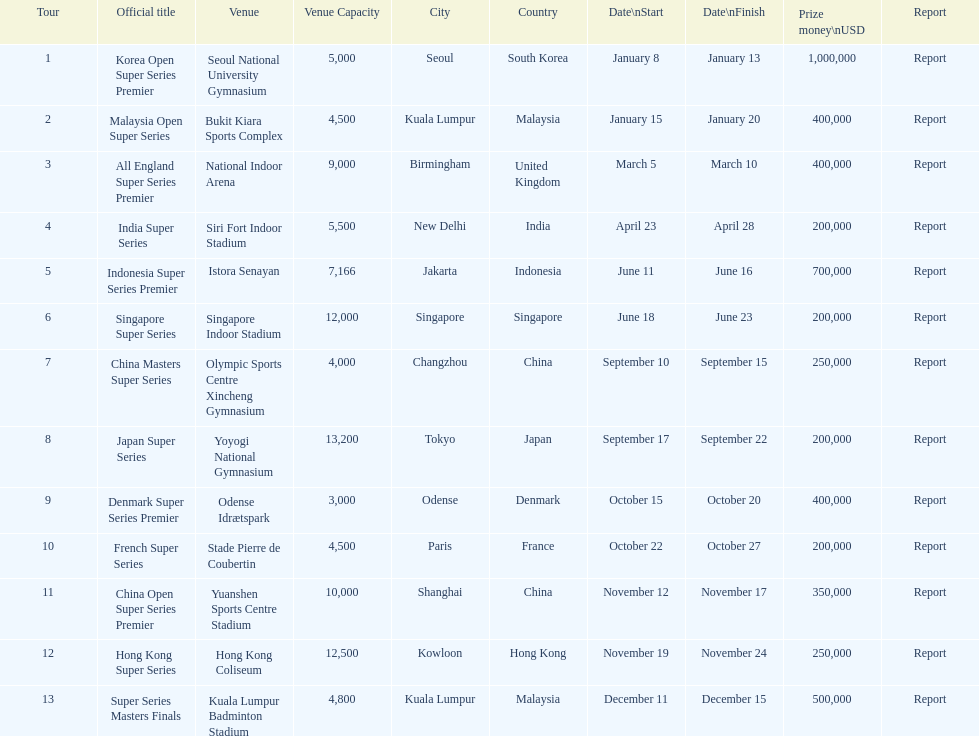What are all the tours? Korea Open Super Series Premier, Malaysia Open Super Series, All England Super Series Premier, India Super Series, Indonesia Super Series Premier, Singapore Super Series, China Masters Super Series, Japan Super Series, Denmark Super Series Premier, French Super Series, China Open Super Series Premier, Hong Kong Super Series, Super Series Masters Finals. What were the start dates of these tours? January 8, January 15, March 5, April 23, June 11, June 18, September 10, September 17, October 15, October 22, November 12, November 19, December 11. Of these, which is in december? December 11. Which tour started on this date? Super Series Masters Finals. 